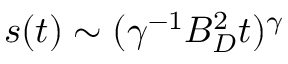Convert formula to latex. <formula><loc_0><loc_0><loc_500><loc_500>s ( t ) \sim ( \gamma ^ { - 1 } B _ { D } ^ { 2 } t ) ^ { \gamma }</formula> 